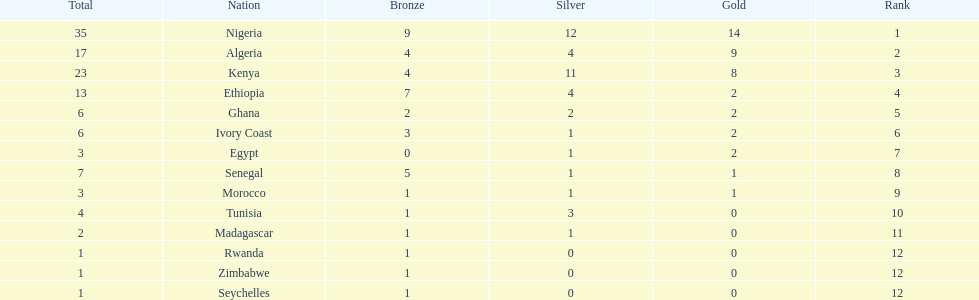What is the appellation of the primary nation displayed on this chart? Nigeria. 